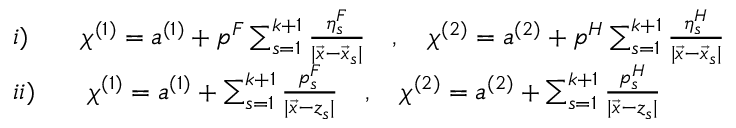<formula> <loc_0><loc_0><loc_500><loc_500>\begin{array} { l } { { i ) \quad \chi ^ { ( 1 ) } = a ^ { ( 1 ) } + p ^ { F } \sum _ { s = 1 } ^ { k + 1 } \frac { \eta _ { s } ^ { F } } { | \vec { x } - \vec { x } _ { s } | } \quad , \quad \chi ^ { ( 2 ) } = a ^ { ( 2 ) } + p ^ { H } \sum _ { s = 1 } ^ { k + 1 } \frac { \eta _ { s } ^ { H } } { | \vec { x } - \vec { x } _ { s } | } } } \\ { { i i ) \quad \chi ^ { ( 1 ) } = a ^ { ( 1 ) } + \sum _ { s = 1 } ^ { k + 1 } \frac { p _ { s } ^ { F } } { | \vec { x } - z _ { s } | } \quad , \quad \chi ^ { ( 2 ) } = a ^ { ( 2 ) } + \sum _ { s = 1 } ^ { k + 1 } \frac { p _ { s } ^ { H } } { | \vec { x } - z _ { s } | } } } \end{array}</formula> 